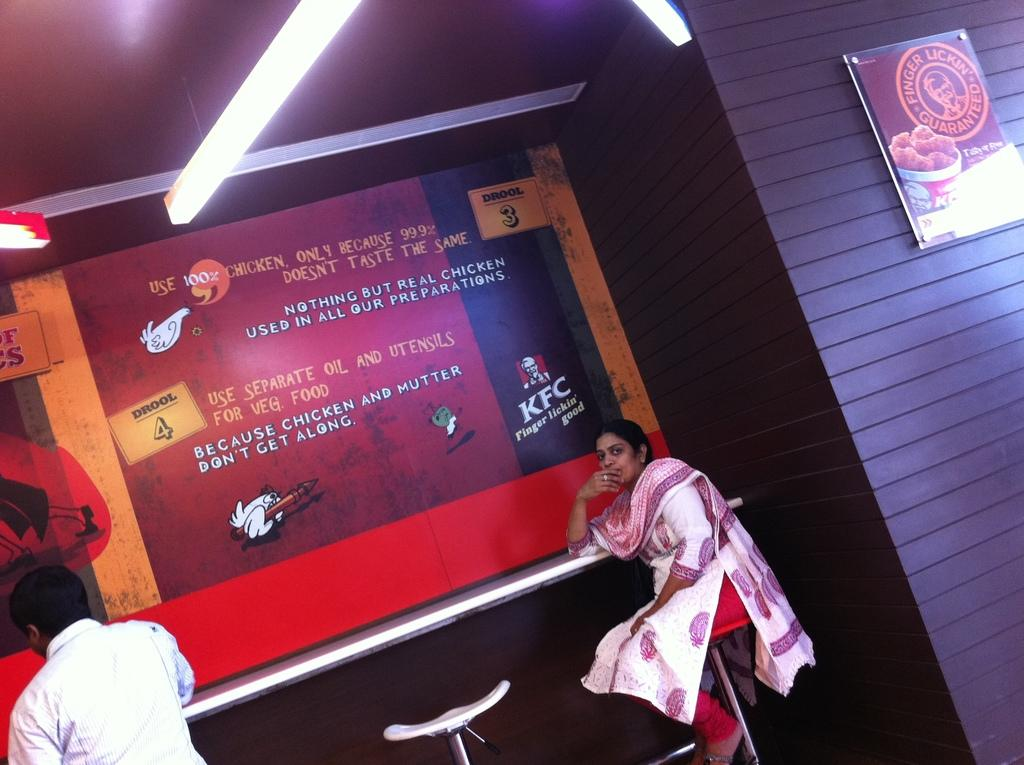<image>
Describe the image concisely. A woman and a man at a table under a KFC sign. 